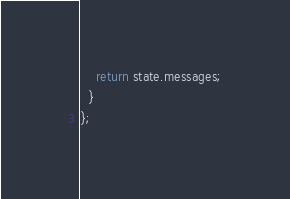<code> <loc_0><loc_0><loc_500><loc_500><_TypeScript_>    return state.messages;
  }
};
</code> 